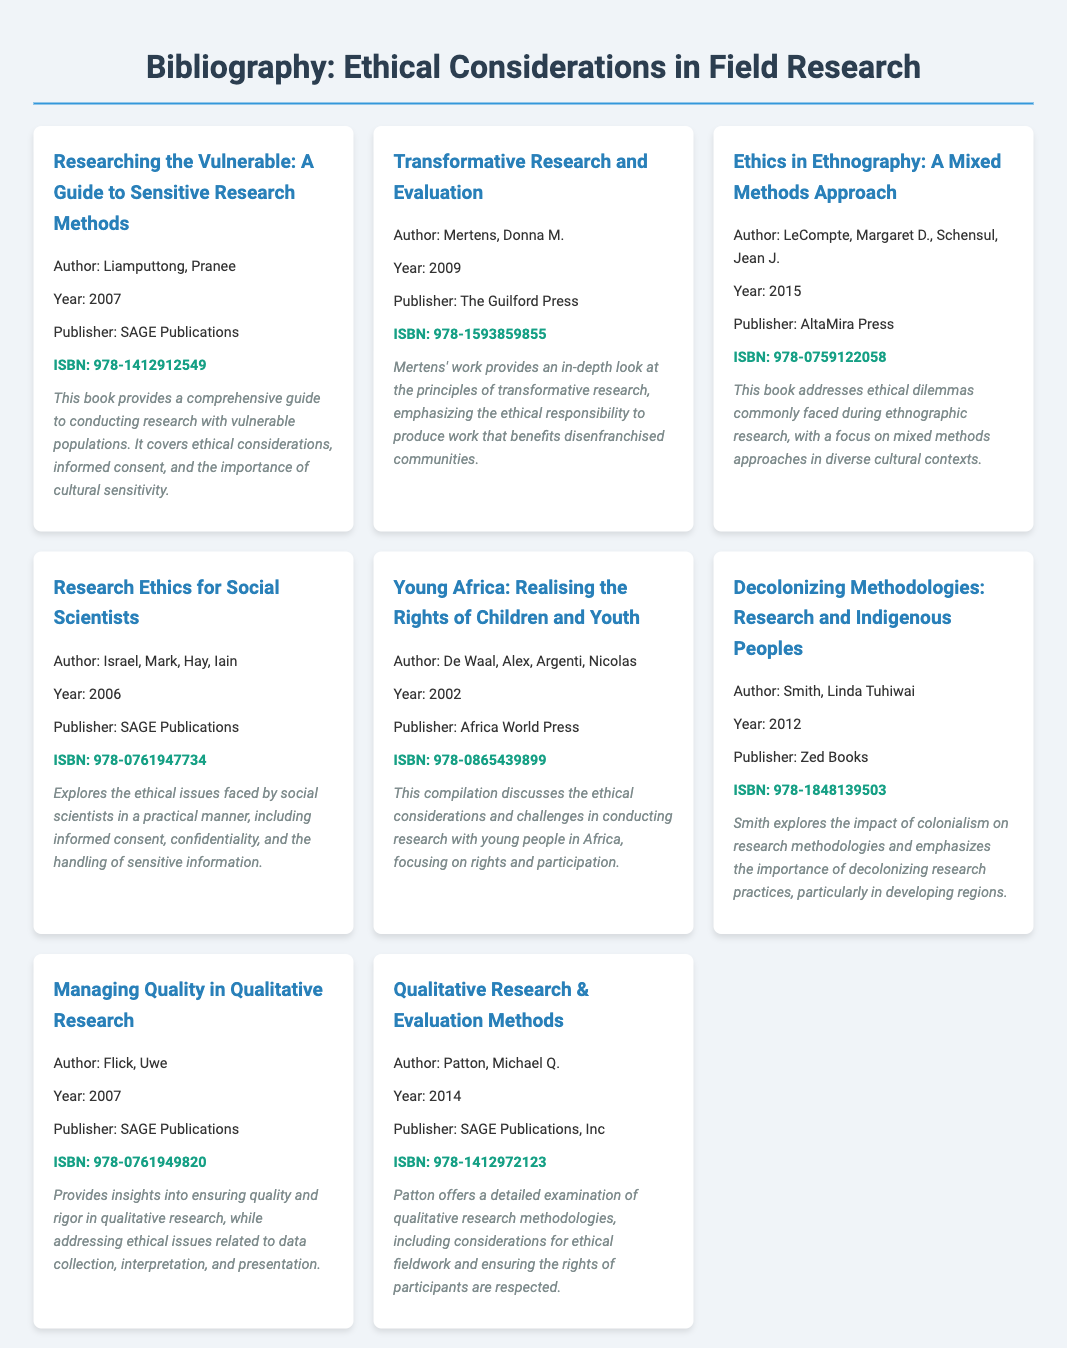What is the title of the first entry? The title of the first entry is clearly mentioned as the first book listed in the bibliography section.
Answer: Researching the Vulnerable: A Guide to Sensitive Research Methods Who is the author of "Transformative Research and Evaluation"? The author's name is provided alongside the book title.
Answer: Donna M. Mertens What year was "Ethics in Ethnography: A Mixed Methods Approach" published? The publication year is stated in the entry details for this book.
Answer: 2015 Which publisher released the book "Young Africa: Realising the Rights of Children and Youth"? The publishing company is listed next to the year in the bibliography entry.
Answer: Africa World Press What is the ISBN of "Decolonizing Methodologies: Research and Indigenous Peoples"? The ISBN is given in bold within the entry for this book.
Answer: 978-1848139503 Which book discusses ethical issues faced by social scientists? This is derived from the title and description of the respective entry in the document.
Answer: Research Ethics for Social Scientists What common theme is emphasized in the works listed in this bibliography? The key theme can be inferred from the titles and descriptions which focus on ethical research practices.
Answer: Ethical considerations How many books are listed in the bibliography? The total count can be determined by counting each individual entry presented in the document.
Answer: 8 